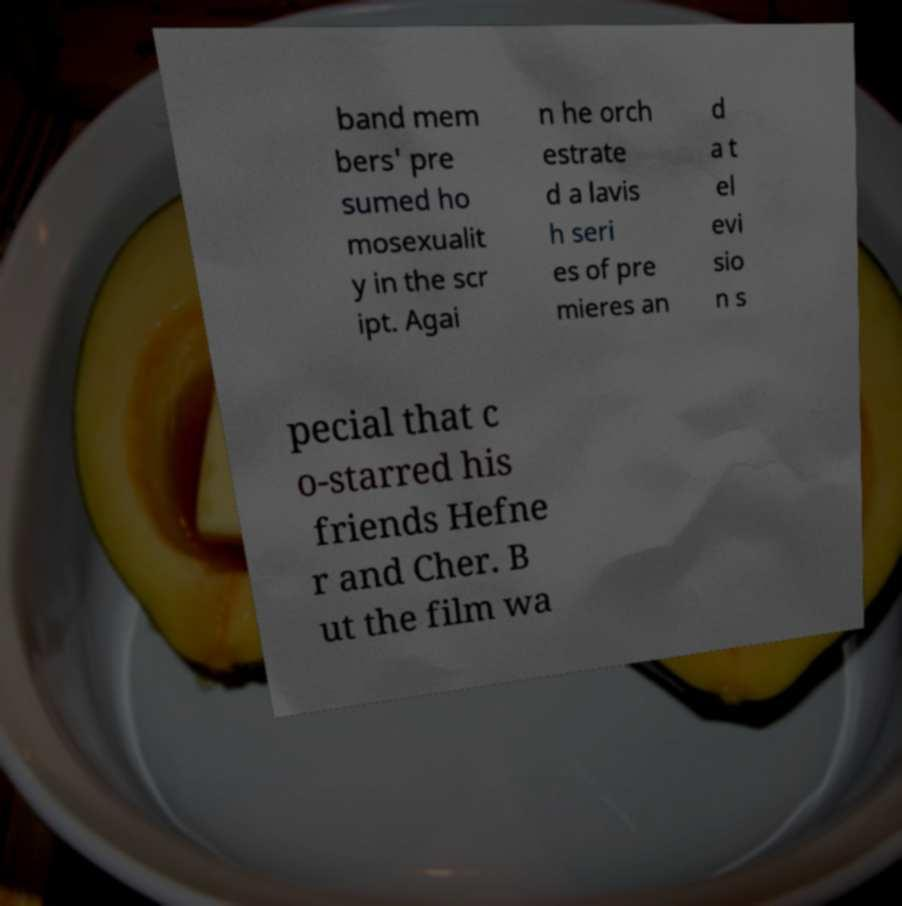Please read and relay the text visible in this image. What does it say? band mem bers' pre sumed ho mosexualit y in the scr ipt. Agai n he orch estrate d a lavis h seri es of pre mieres an d a t el evi sio n s pecial that c o-starred his friends Hefne r and Cher. B ut the film wa 